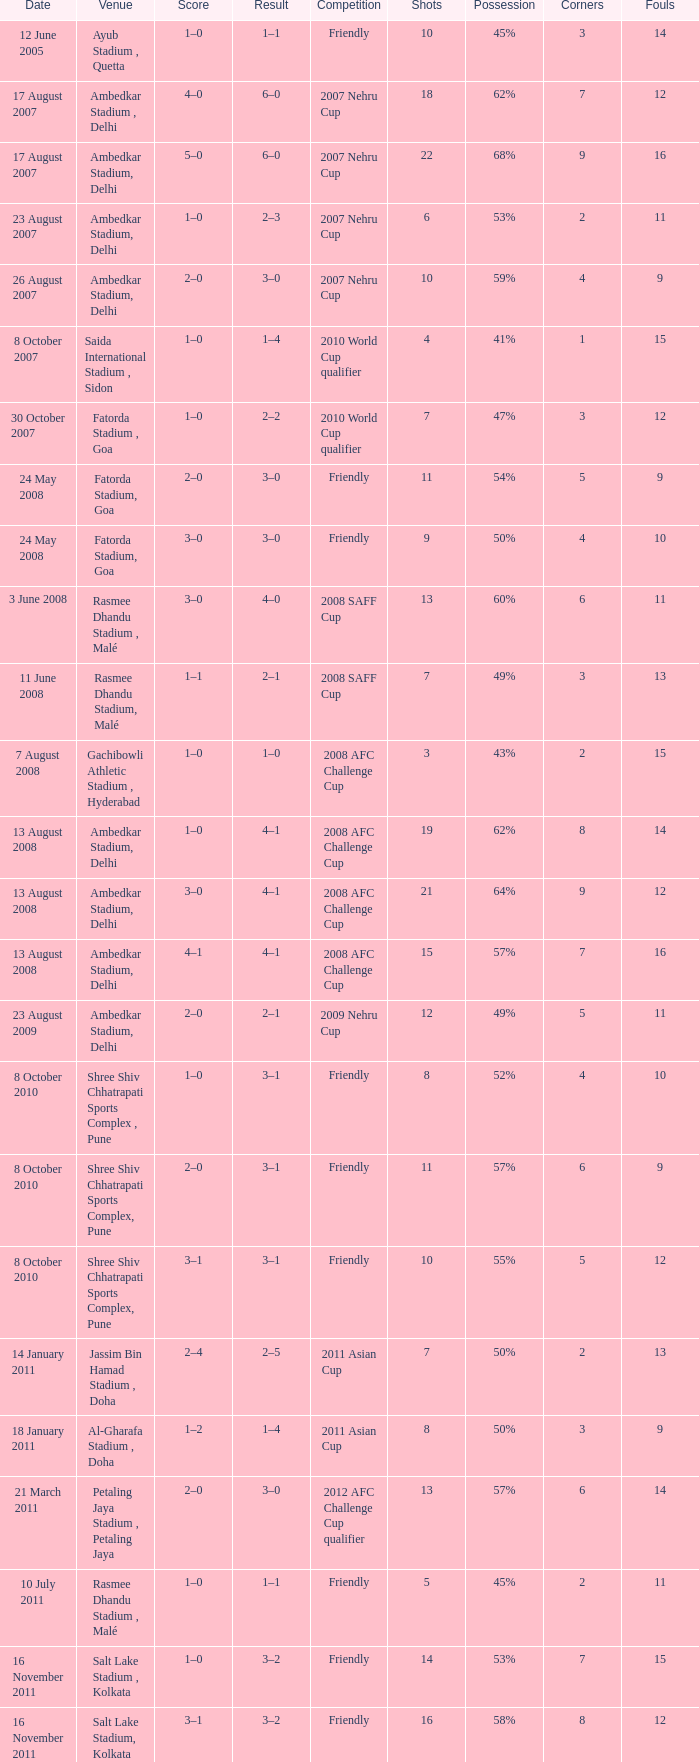Tell me the score on 22 august 2012 1–0. 